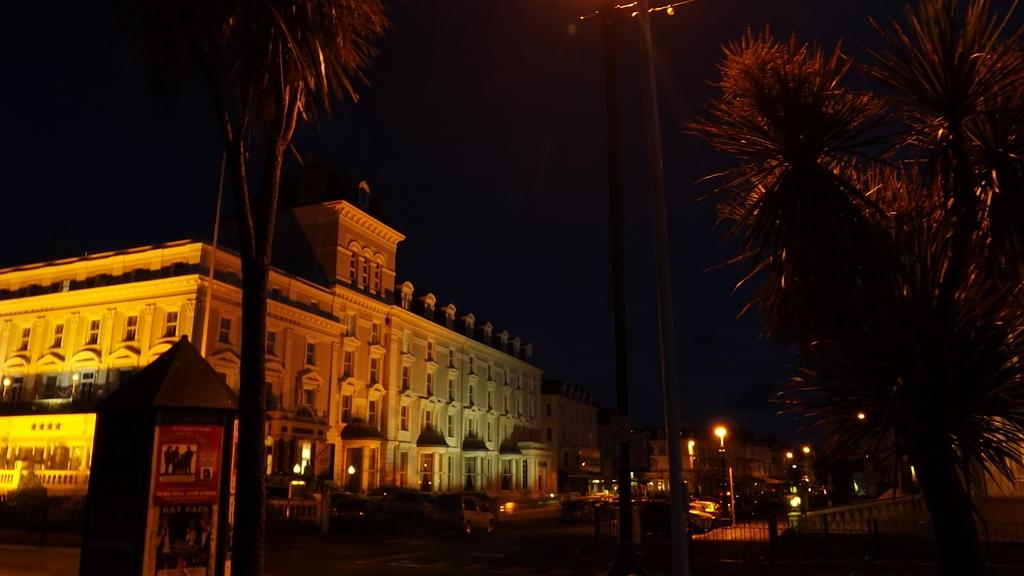What type of natural elements can be seen in the image? There are trees in the image. What type of artificial elements can be seen in the image? There are street lamps and buildings in the image. Are there any living beings present in the image? Yes, there are people in the image. What is visible at the top of the image? The sky is visible at the top of the image. What type of gold object can be seen on the ground in the image? There is no gold object present on the ground in the image. What type of crack is visible on the street lamps in the image? There are no cracks visible on the street lamps in the image. 